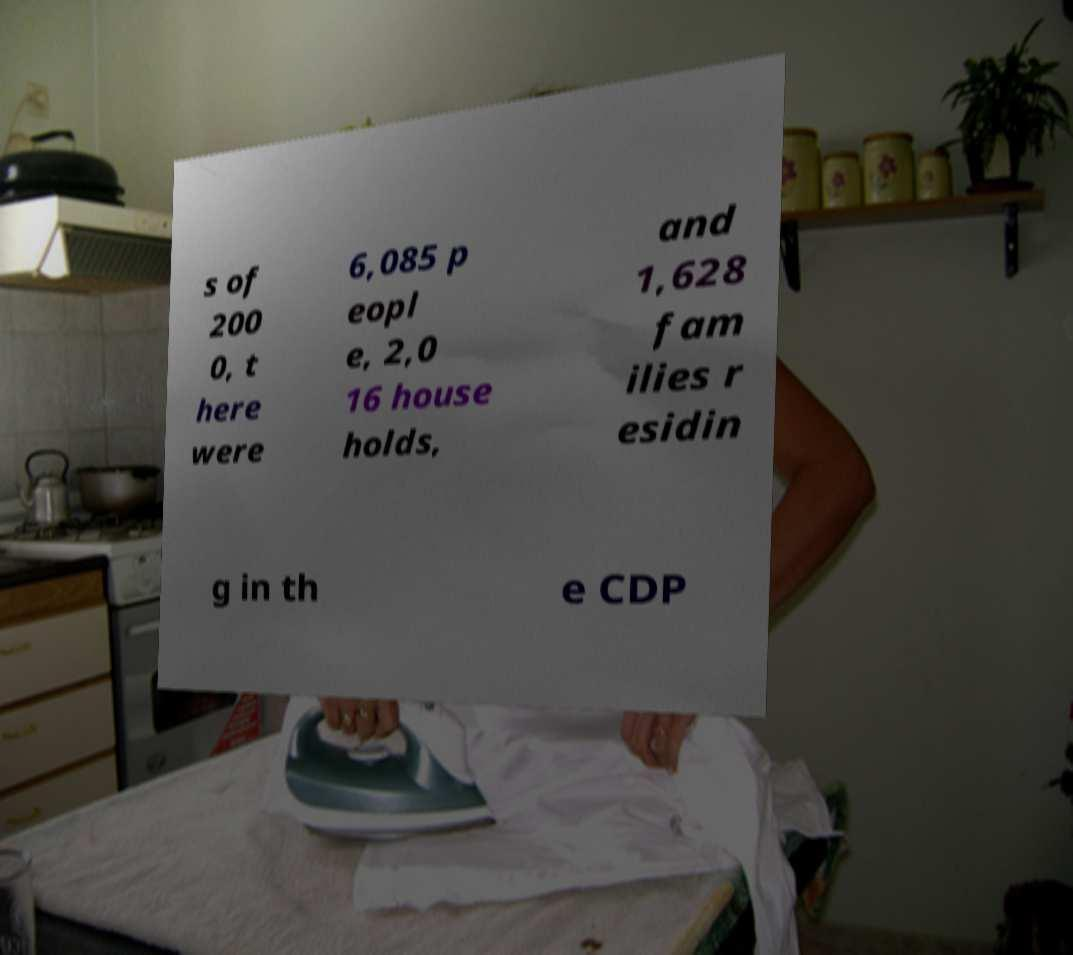For documentation purposes, I need the text within this image transcribed. Could you provide that? s of 200 0, t here were 6,085 p eopl e, 2,0 16 house holds, and 1,628 fam ilies r esidin g in th e CDP 